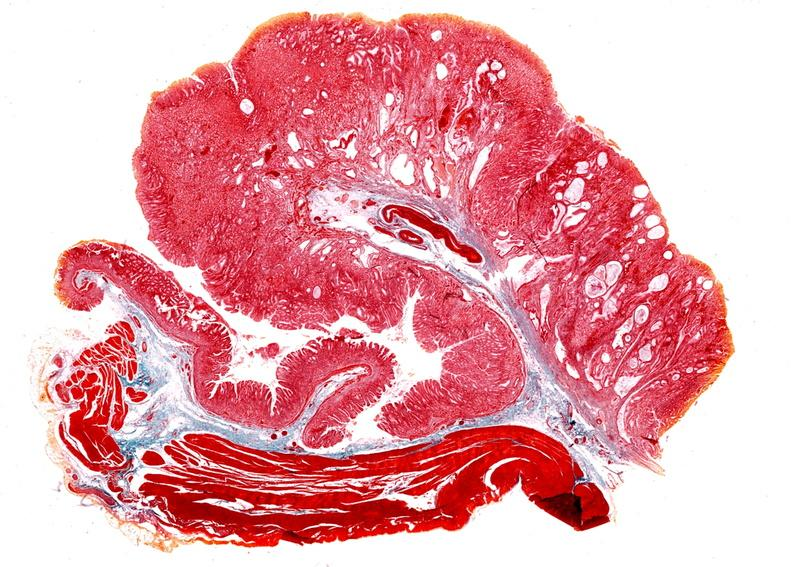where is this from?
Answer the question using a single word or phrase. Gastrointestinal system 